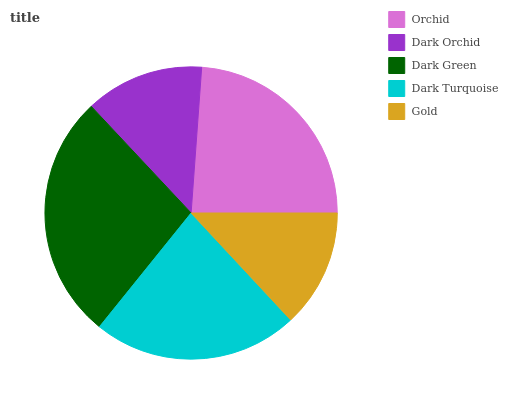Is Gold the minimum?
Answer yes or no. Yes. Is Dark Green the maximum?
Answer yes or no. Yes. Is Dark Orchid the minimum?
Answer yes or no. No. Is Dark Orchid the maximum?
Answer yes or no. No. Is Orchid greater than Dark Orchid?
Answer yes or no. Yes. Is Dark Orchid less than Orchid?
Answer yes or no. Yes. Is Dark Orchid greater than Orchid?
Answer yes or no. No. Is Orchid less than Dark Orchid?
Answer yes or no. No. Is Dark Turquoise the high median?
Answer yes or no. Yes. Is Dark Turquoise the low median?
Answer yes or no. Yes. Is Dark Green the high median?
Answer yes or no. No. Is Dark Green the low median?
Answer yes or no. No. 